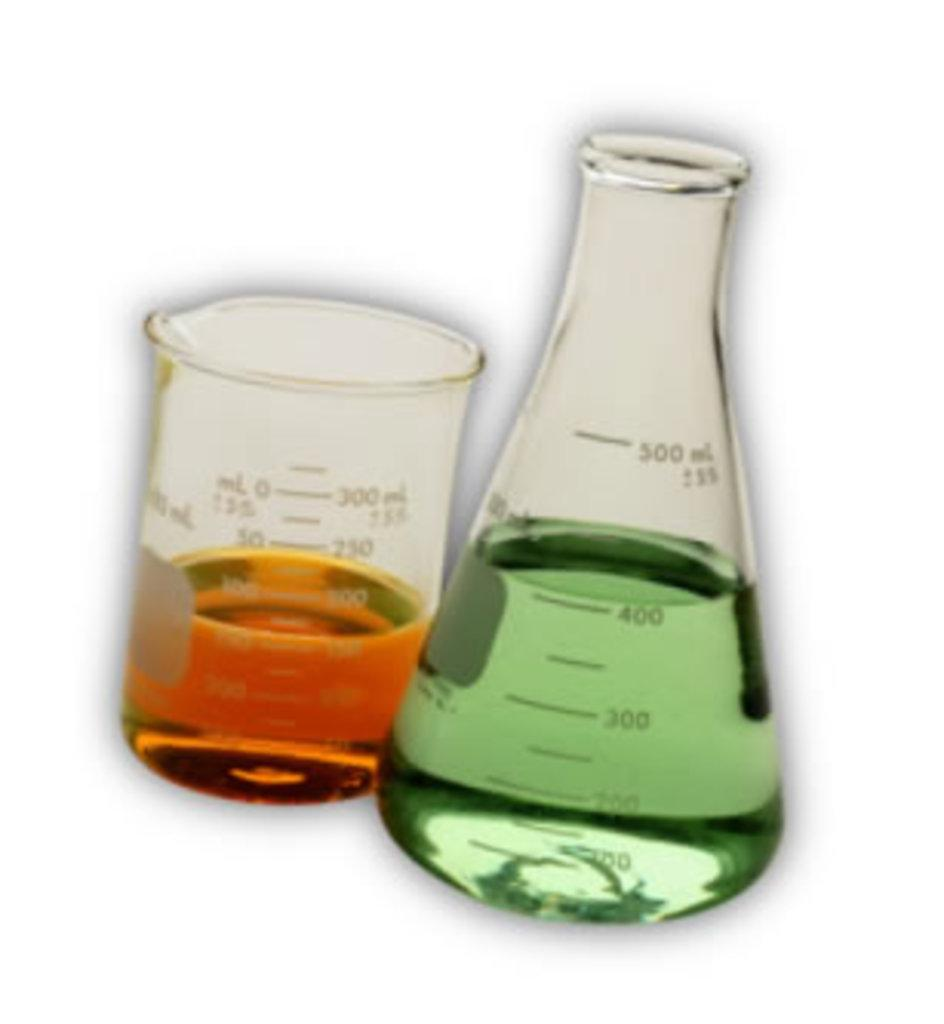Provide a one-sentence caption for the provided image. two scientific measuring cups with a green liquid measuring 400 ML. 